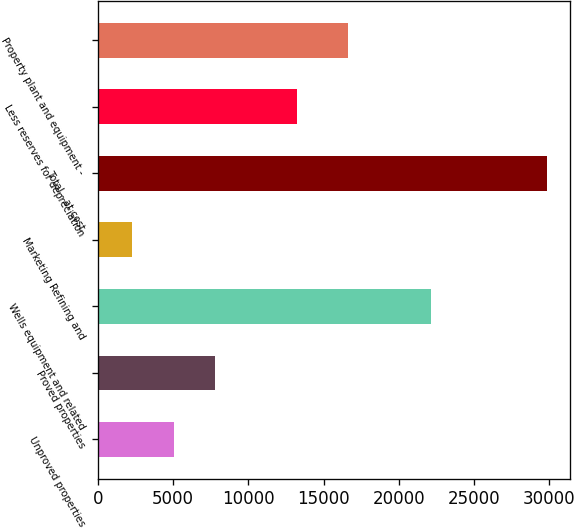Convert chart to OTSL. <chart><loc_0><loc_0><loc_500><loc_500><bar_chart><fcel>Unproved properties<fcel>Proved properties<fcel>Wells equipment and related<fcel>Marketing Refining and<fcel>Total - at cost<fcel>Less reserves for depreciation<fcel>Property plant and equipment -<nl><fcel>5043.6<fcel>7802.2<fcel>22118<fcel>2285<fcel>29871<fcel>13244<fcel>16627<nl></chart> 